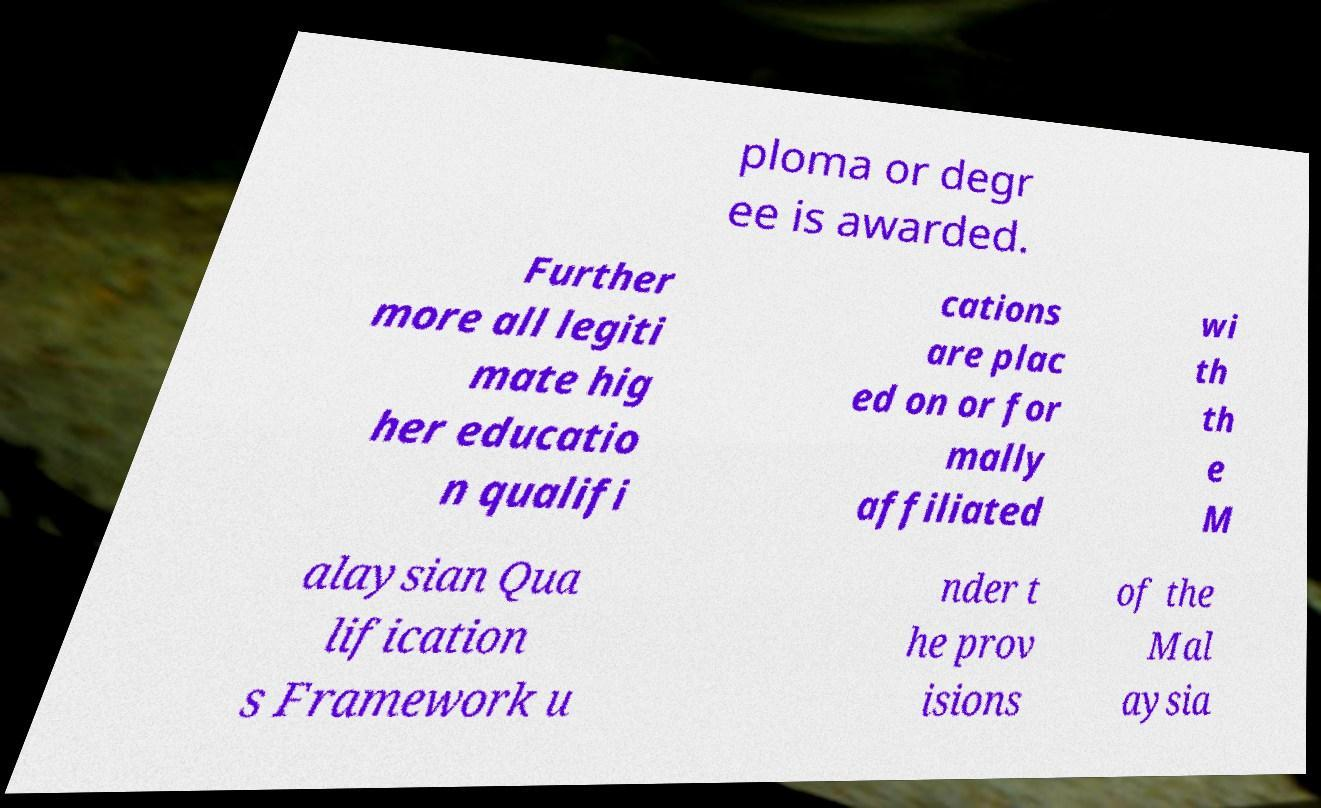Can you accurately transcribe the text from the provided image for me? ploma or degr ee is awarded. Further more all legiti mate hig her educatio n qualifi cations are plac ed on or for mally affiliated wi th th e M alaysian Qua lification s Framework u nder t he prov isions of the Mal aysia 